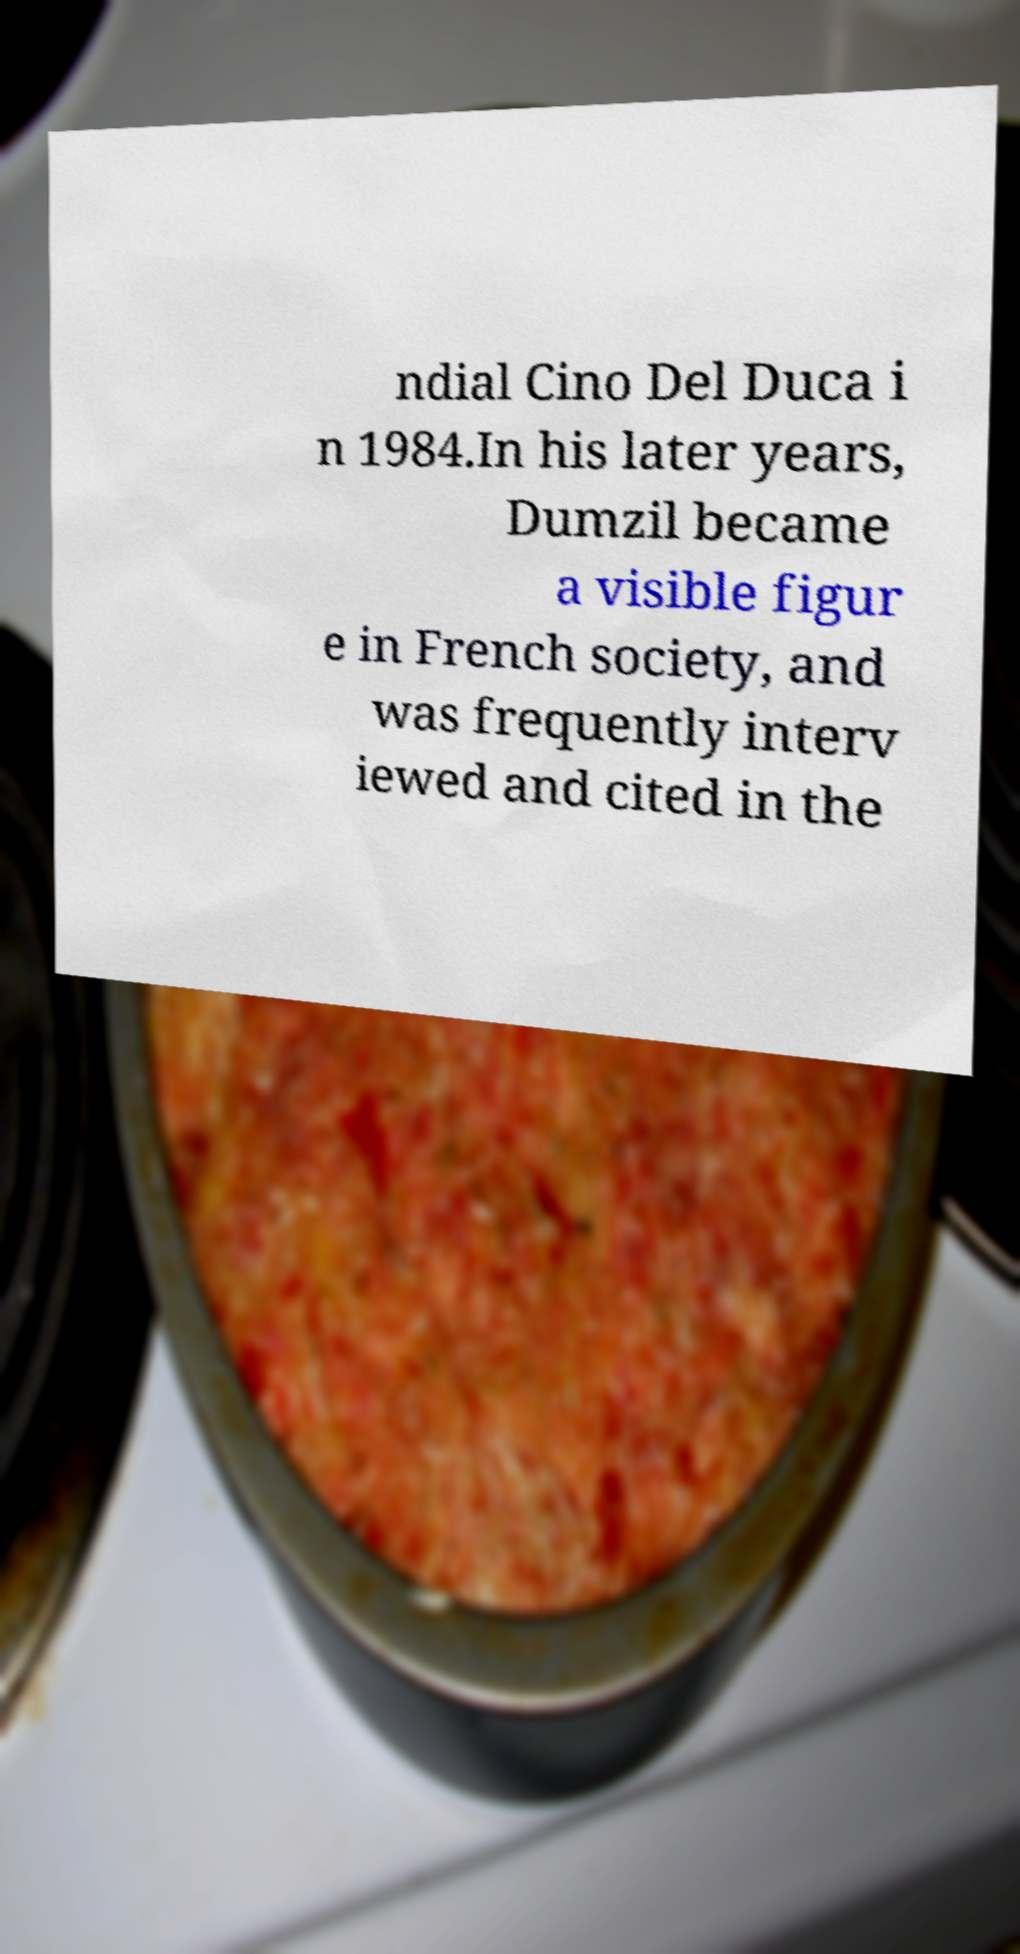There's text embedded in this image that I need extracted. Can you transcribe it verbatim? ndial Cino Del Duca i n 1984.In his later years, Dumzil became a visible figur e in French society, and was frequently interv iewed and cited in the 